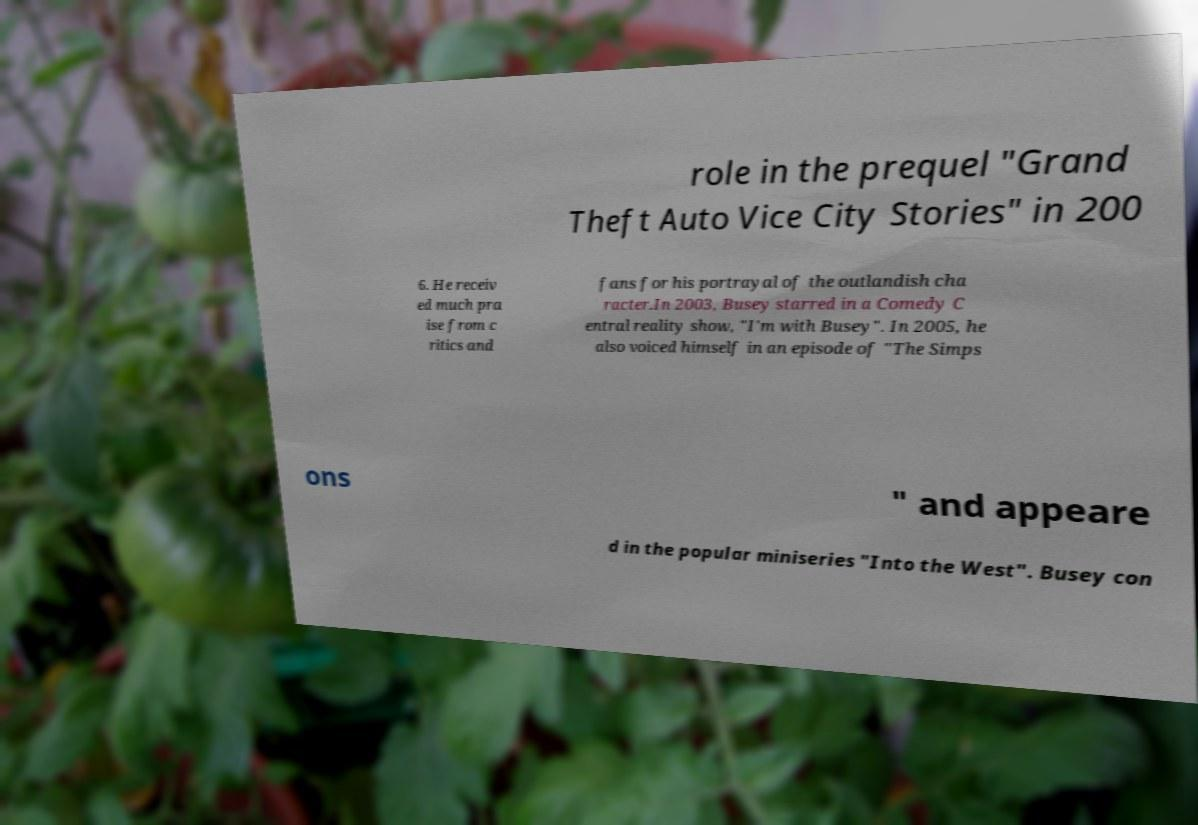Can you accurately transcribe the text from the provided image for me? role in the prequel "Grand Theft Auto Vice City Stories" in 200 6. He receiv ed much pra ise from c ritics and fans for his portrayal of the outlandish cha racter.In 2003, Busey starred in a Comedy C entral reality show, "I'm with Busey". In 2005, he also voiced himself in an episode of "The Simps ons " and appeare d in the popular miniseries "Into the West". Busey con 